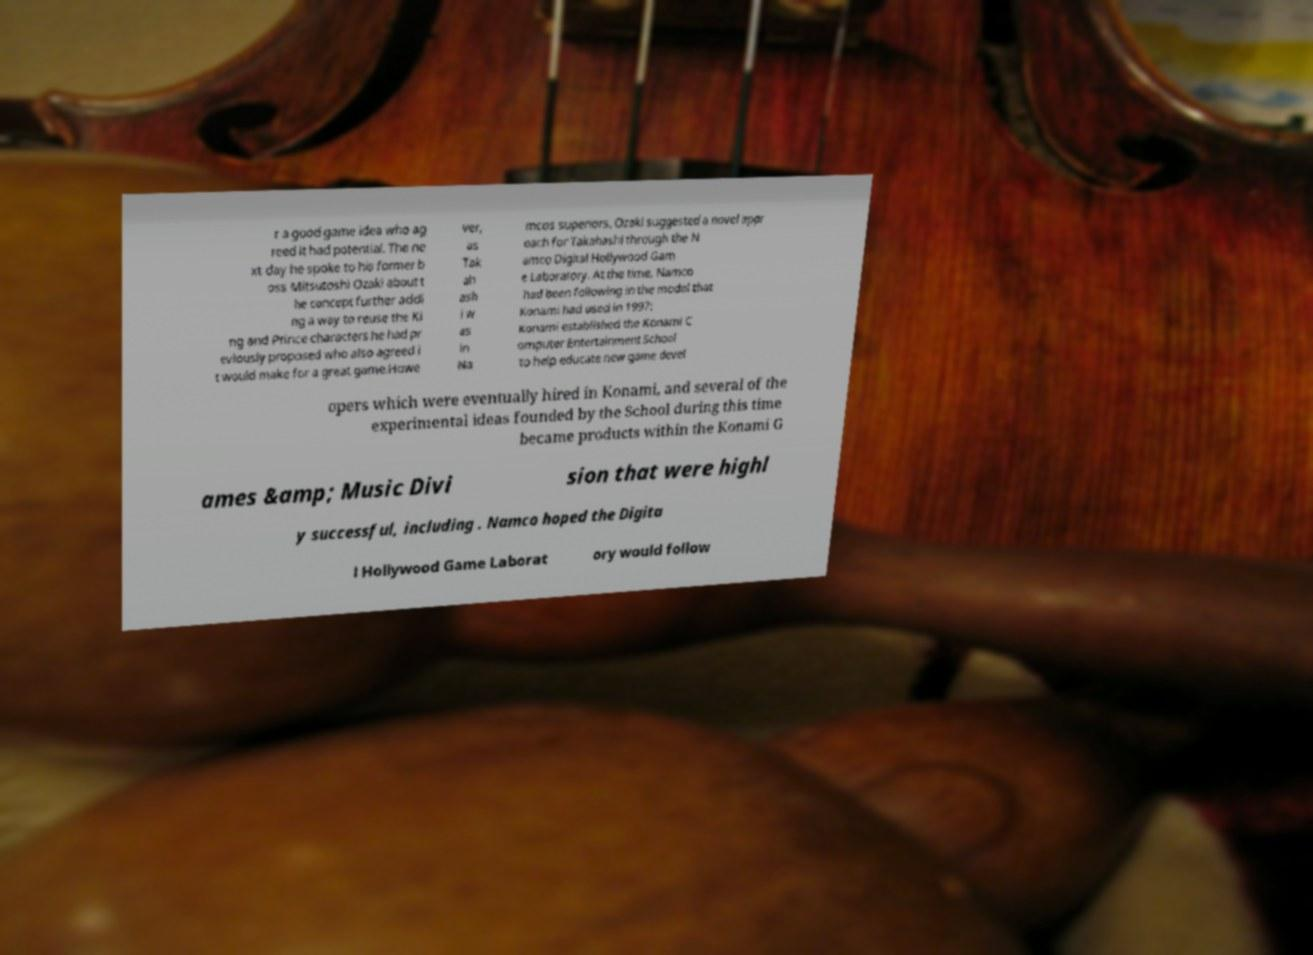Could you assist in decoding the text presented in this image and type it out clearly? r a good game idea who ag reed it had potential. The ne xt day he spoke to his former b oss Mitsutoshi Ozaki about t he concept further addi ng a way to reuse the Ki ng and Prince characters he had pr eviously proposed who also agreed i t would make for a great game.Howe ver, as Tak ah ash i w as in Na mcos superiors. Ozaki suggested a novel appr oach for Takahashi through the N amco Digital Hollywood Gam e Laboratory. At the time, Namco had been following in the model that Konami had used in 1997: Konami established the Konami C omputer Entertainment School to help educate new game devel opers which were eventually hired in Konami, and several of the experimental ideas founded by the School during this time became products within the Konami G ames &amp; Music Divi sion that were highl y successful, including . Namco hoped the Digita l Hollywood Game Laborat ory would follow 